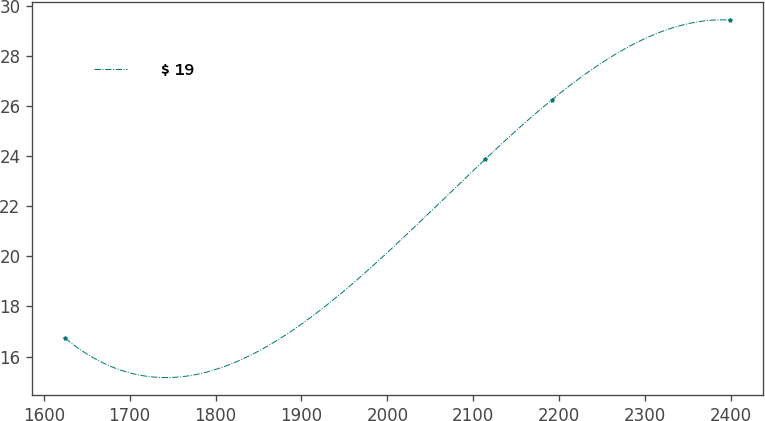<chart> <loc_0><loc_0><loc_500><loc_500><line_chart><ecel><fcel>$ 19<nl><fcel>1625.14<fcel>16.73<nl><fcel>2114.06<fcel>23.88<nl><fcel>2191.41<fcel>26.24<nl><fcel>2398.65<fcel>29.42<nl></chart> 